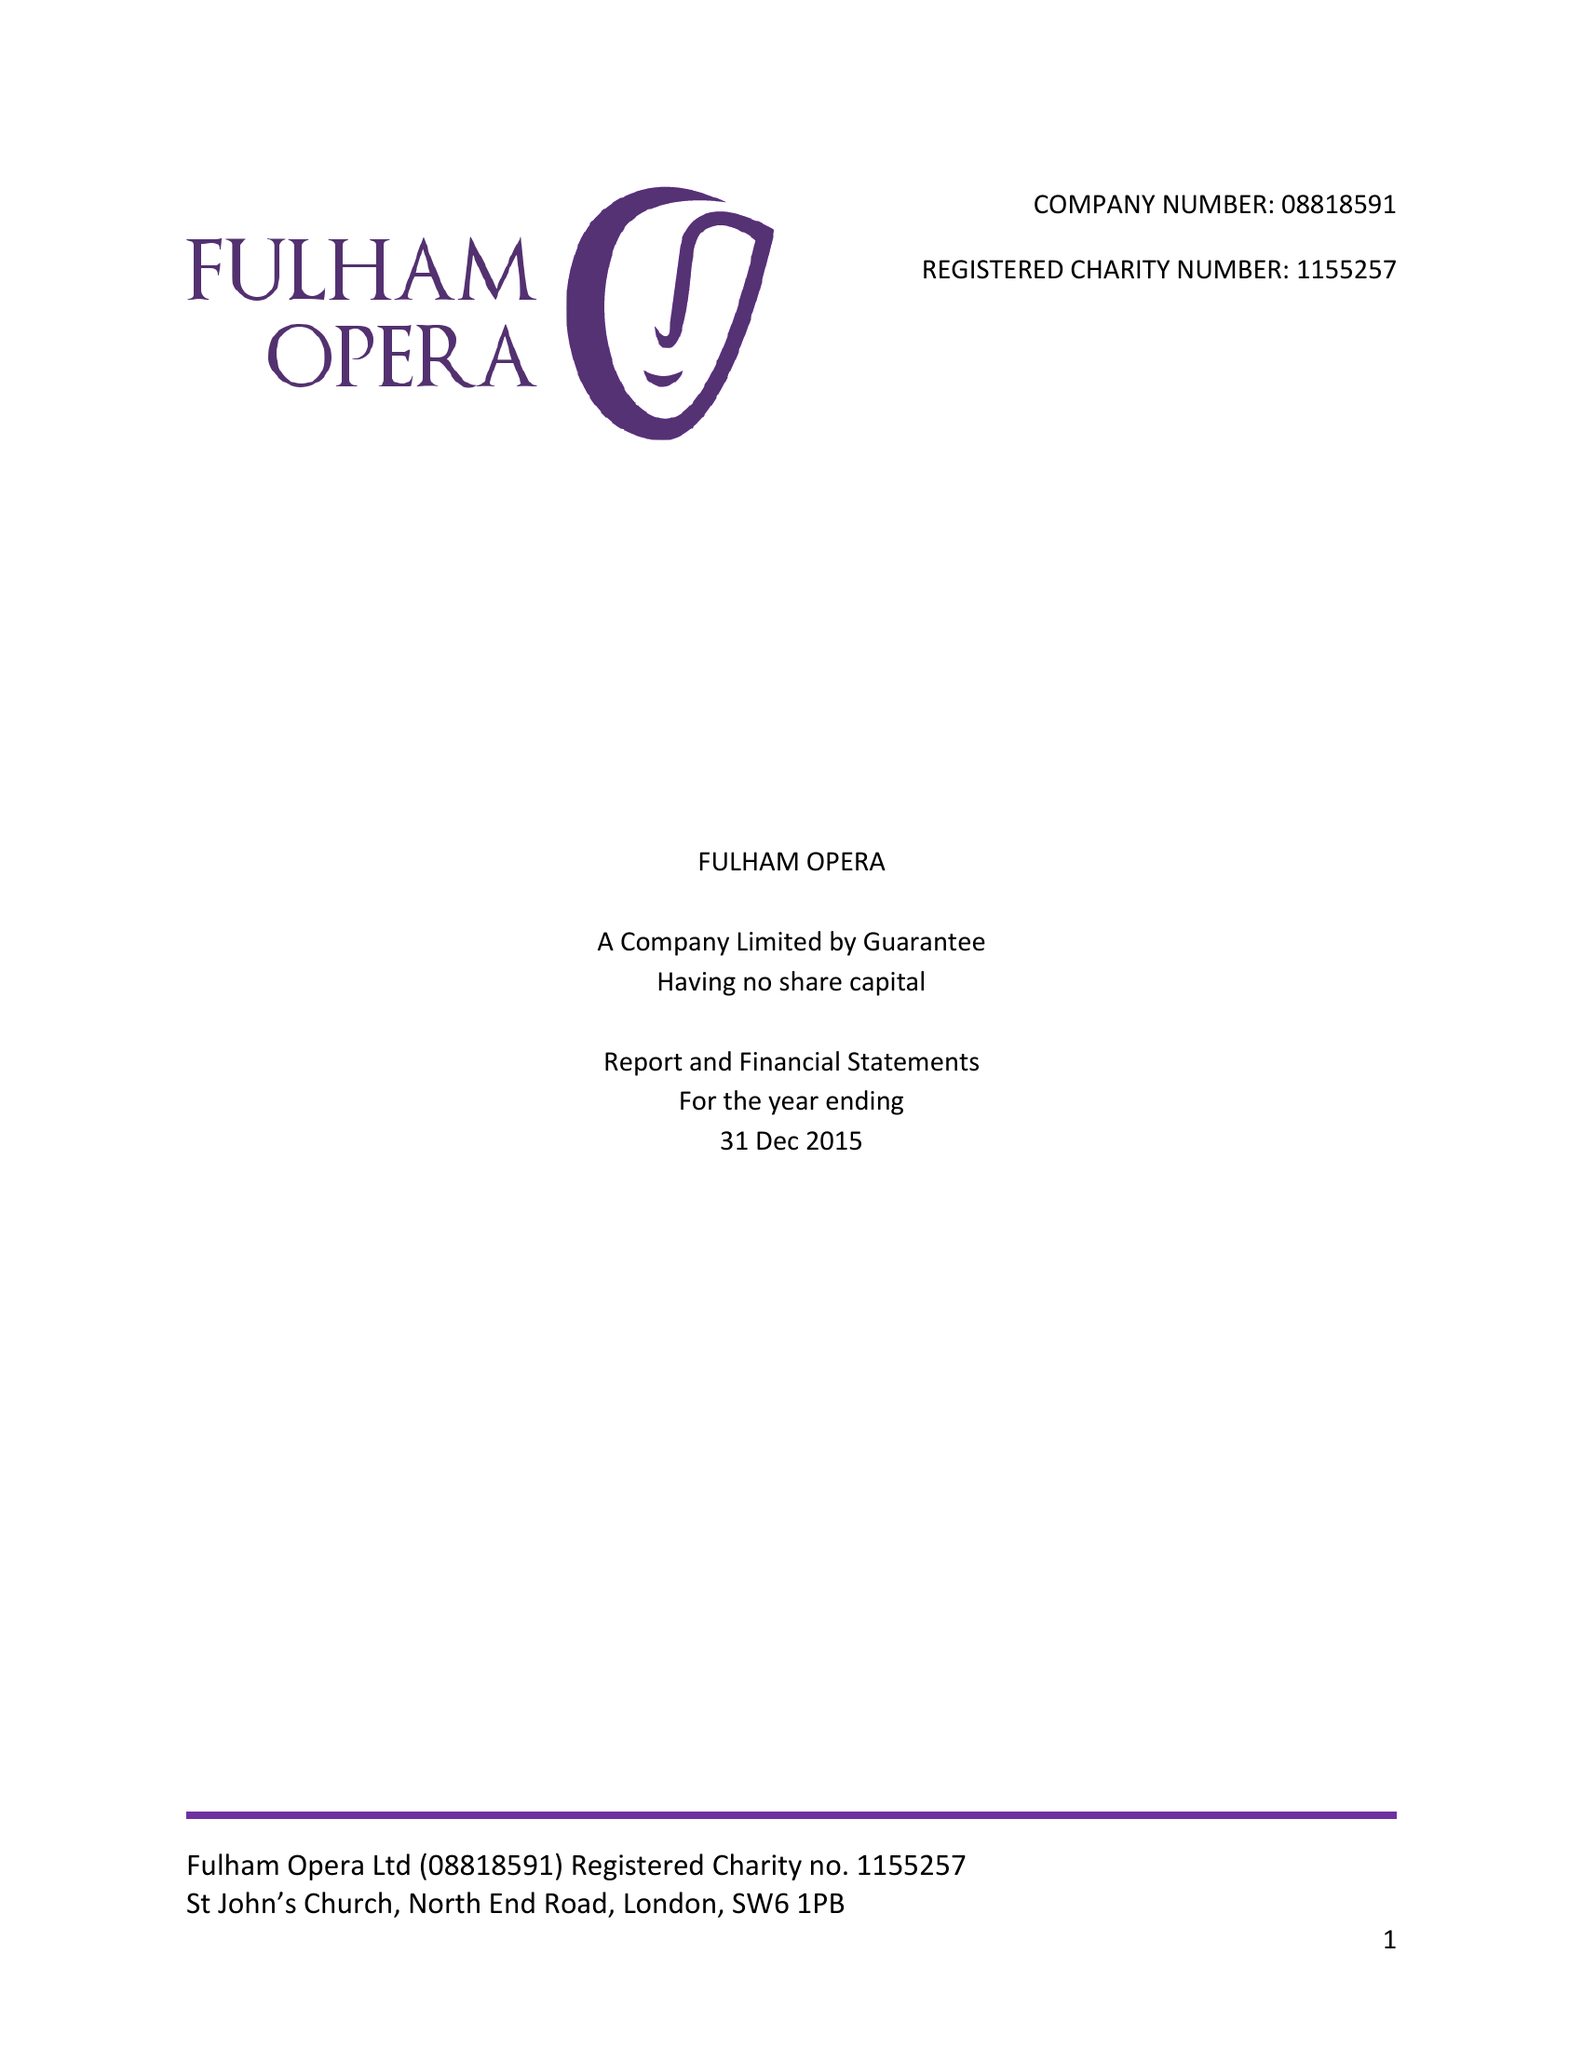What is the value for the income_annually_in_british_pounds?
Answer the question using a single word or phrase. 49828.00 